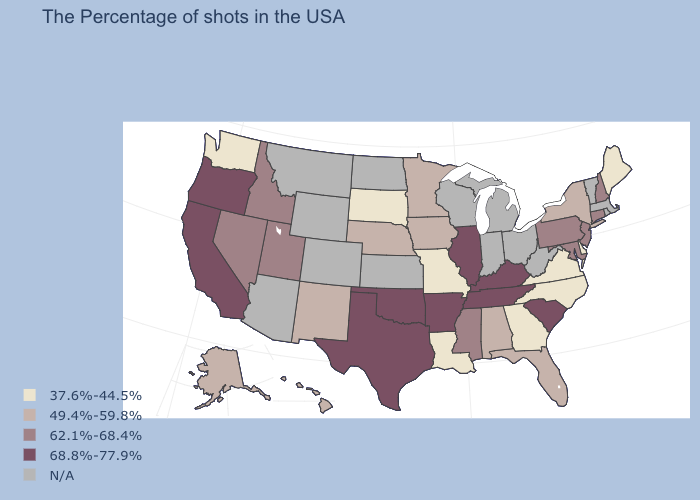What is the highest value in the MidWest ?
Concise answer only. 68.8%-77.9%. Is the legend a continuous bar?
Short answer required. No. Name the states that have a value in the range 37.6%-44.5%?
Be succinct. Maine, Delaware, Virginia, North Carolina, Georgia, Louisiana, Missouri, South Dakota, Washington. What is the value of Rhode Island?
Short answer required. N/A. Among the states that border Pennsylvania , does New York have the highest value?
Concise answer only. No. What is the value of Vermont?
Concise answer only. N/A. What is the lowest value in the Northeast?
Give a very brief answer. 37.6%-44.5%. Which states have the lowest value in the West?
Concise answer only. Washington. What is the value of Oklahoma?
Give a very brief answer. 68.8%-77.9%. Among the states that border Rhode Island , which have the highest value?
Write a very short answer. Connecticut. Does Oregon have the highest value in the USA?
Give a very brief answer. Yes. What is the highest value in the USA?
Answer briefly. 68.8%-77.9%. What is the value of Alaska?
Concise answer only. 49.4%-59.8%. Name the states that have a value in the range 49.4%-59.8%?
Quick response, please. New York, Florida, Alabama, Minnesota, Iowa, Nebraska, New Mexico, Alaska, Hawaii. 